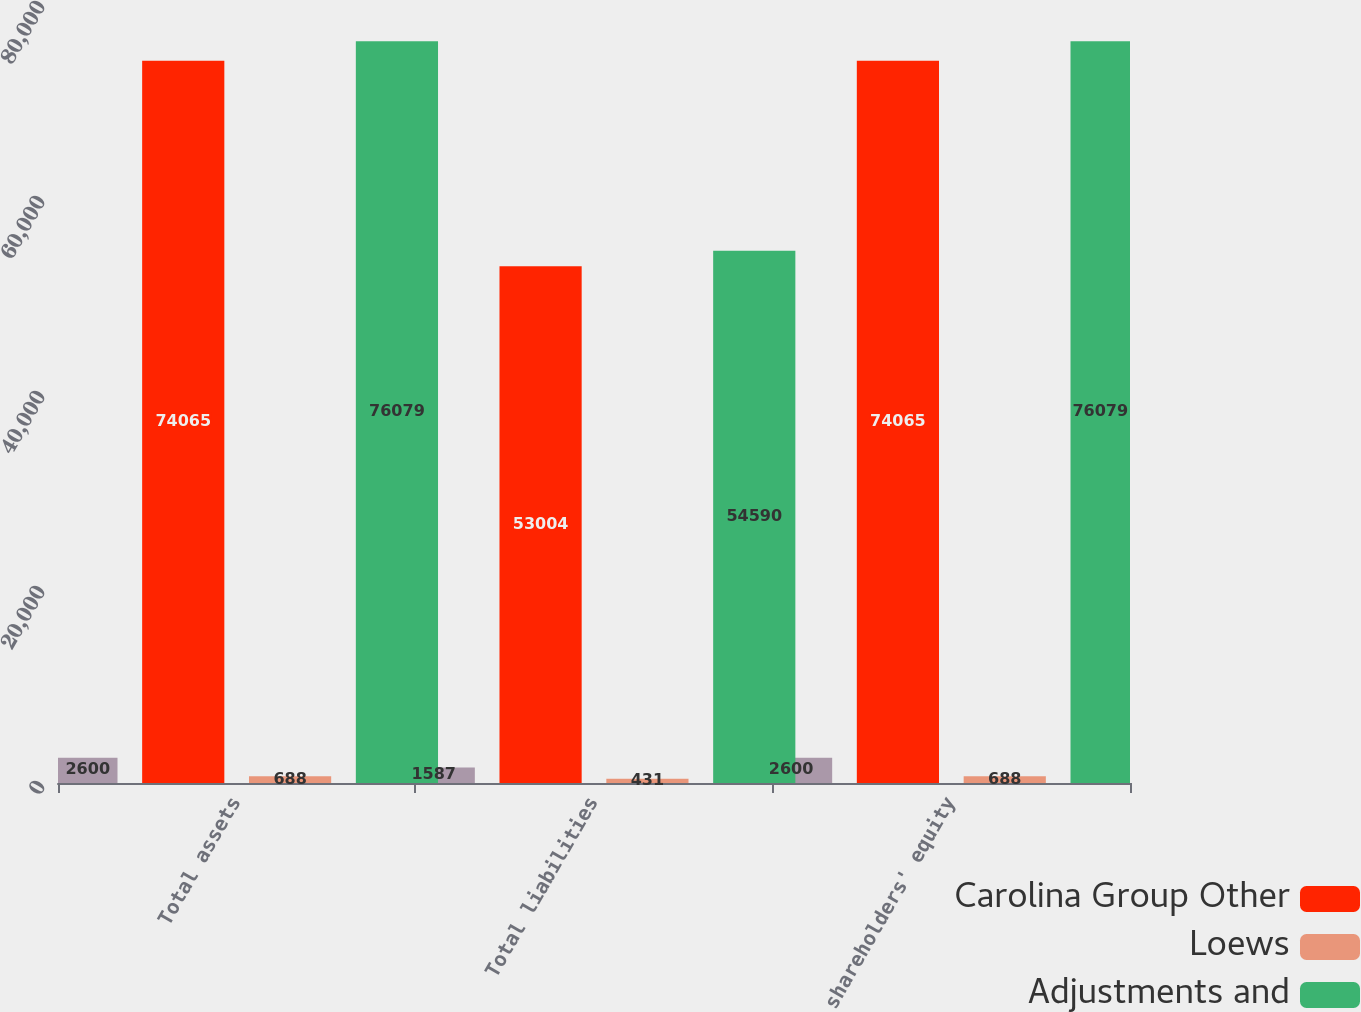Convert chart. <chart><loc_0><loc_0><loc_500><loc_500><stacked_bar_chart><ecel><fcel>Total assets<fcel>Total liabilities<fcel>shareholders' equity<nl><fcel>nan<fcel>2600<fcel>1587<fcel>2600<nl><fcel>Carolina Group Other<fcel>74065<fcel>53004<fcel>74065<nl><fcel>Loews<fcel>688<fcel>431<fcel>688<nl><fcel>Adjustments and<fcel>76079<fcel>54590<fcel>76079<nl></chart> 